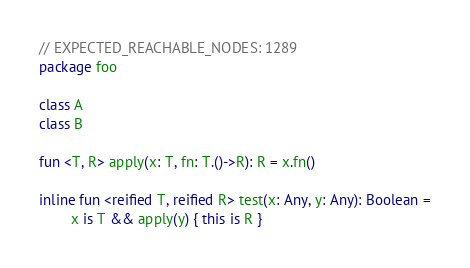<code> <loc_0><loc_0><loc_500><loc_500><_Kotlin_>// EXPECTED_REACHABLE_NODES: 1289
package foo

class A
class B

fun <T, R> apply(x: T, fn: T.()->R): R = x.fn()

inline fun <reified T, reified R> test(x: Any, y: Any): Boolean =
        x is T && apply(y) { this is R }
</code> 